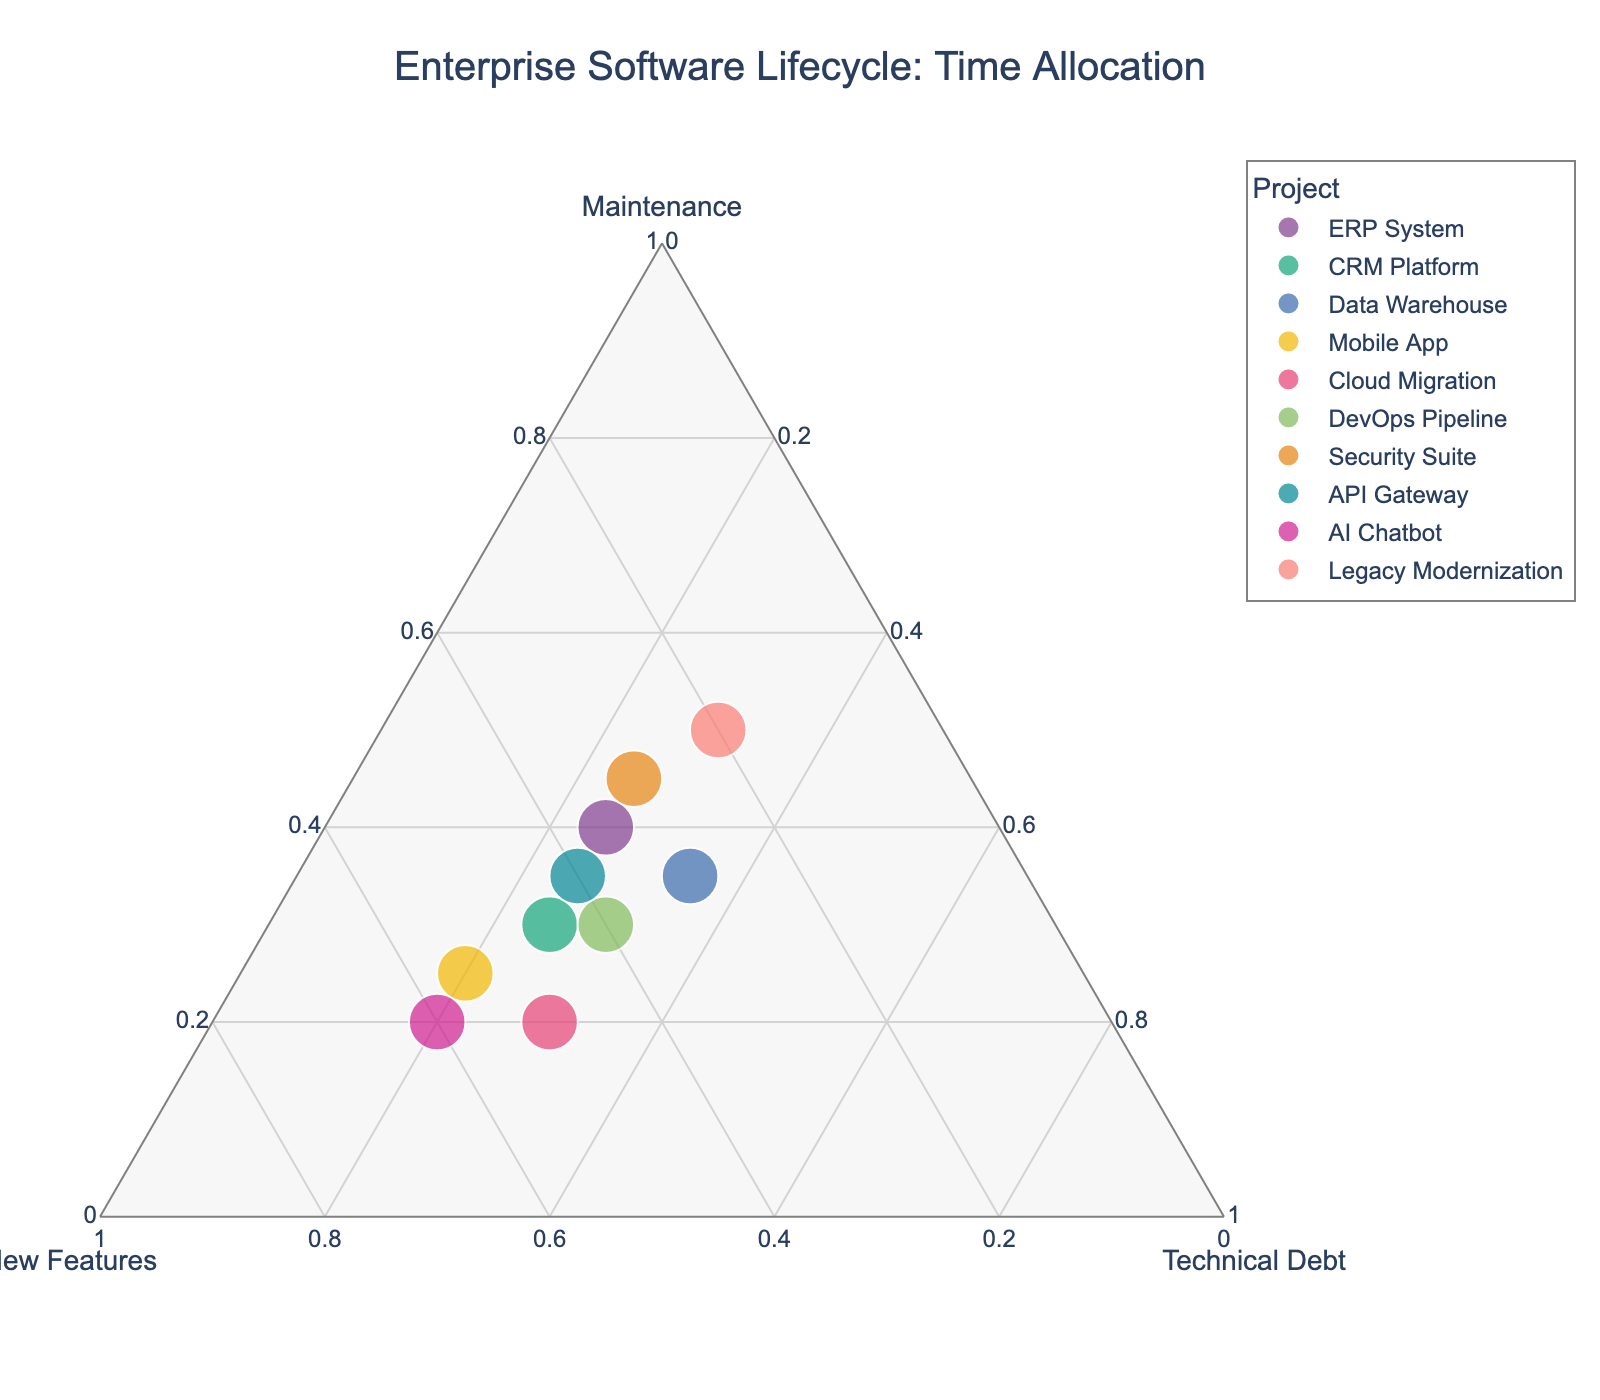What's the title of the plot? The title of the plot is displayed at the top of the figure. You can see it labeled as "Enterprise Software Lifecycle: Time Allocation."
Answer: Enterprise Software Lifecycle: Time Allocation How many projects are represented in the plot? To find the number of projects, count the distinct markers in the ternary plot. The plot includes markers for each project listed in the data. There are 10 projects in total.
Answer: 10 Which project spends the most time on new features? Locate the marker positioned closest to the "New Features" axis which indicates a higher proportion of time spent on new features. The "AI Chatbot" is positioned nearest to the "New Features" axis.
Answer: AI Chatbot What project spends the highest portion of time on maintenance? Look for the marker closest to the "Maintenance" axis, implying the highest allocation towards maintenance. "Legacy Modernization" is nearest to this corner, representing the highest maintenance time.
Answer: Legacy Modernization Which two projects allocate exactly 25% to technical debt? Identify markers where the "Technical Debt" component is exactly 25%. Both "ERP System" and "CRM Platform" allocate 25% of their time to technical debt reduction.
Answer: ERP System, CRM Platform Compare the time spent on maintenance by the "ERP System" and the "Security Suite". Which one spends more? On the ternary plot, locate the points for "ERP System" and "Security Suite" relative to the "Maintenance" axis. The "Security Suite" positioned closer to the "Maintenance" corner spends more time on maintenance compared to the "ERP System."
Answer: Security Suite What is the sum of the time spent on maintenance for the "Mobile App" and "Cloud Migration"? Look at the positions of "Mobile App" and "Cloud Migration" relative to the "Maintenance" axis. The "Mobile App" spends 25% on maintenance and "Cloud Migration" spends 20%. Summing these values: 25% + 20% = 45%.
Answer: 45% Which project has an equal proportion of time spent on new features and technical debt? Check for markers where the proportions for new features and technical debt are equal. "DevOps Pipeline" and "Cloud Migration" spend equal amounts (both 40% and 30% respectively) on new features and technical debt.
Answer: DevOps Pipeline, Cloud Migration Is there any project that spends less than 20% on maintenance? Identify any markers positioned closer towards the "New Features" and "Technical Debt" corners, implying less time spent on maintenance. There is no project spending less than 20% on maintenance as all markers are 20% or higher.
Answer: No Which project has the most balanced time allocation across all three categories? A balanced allocation means the project marker should be near the center of the ternary plot, indicating similar proportions across categories. The "Data Warehouse" is positioned centrally indicating a more balanced distribution of time.
Answer: Data Warehouse 